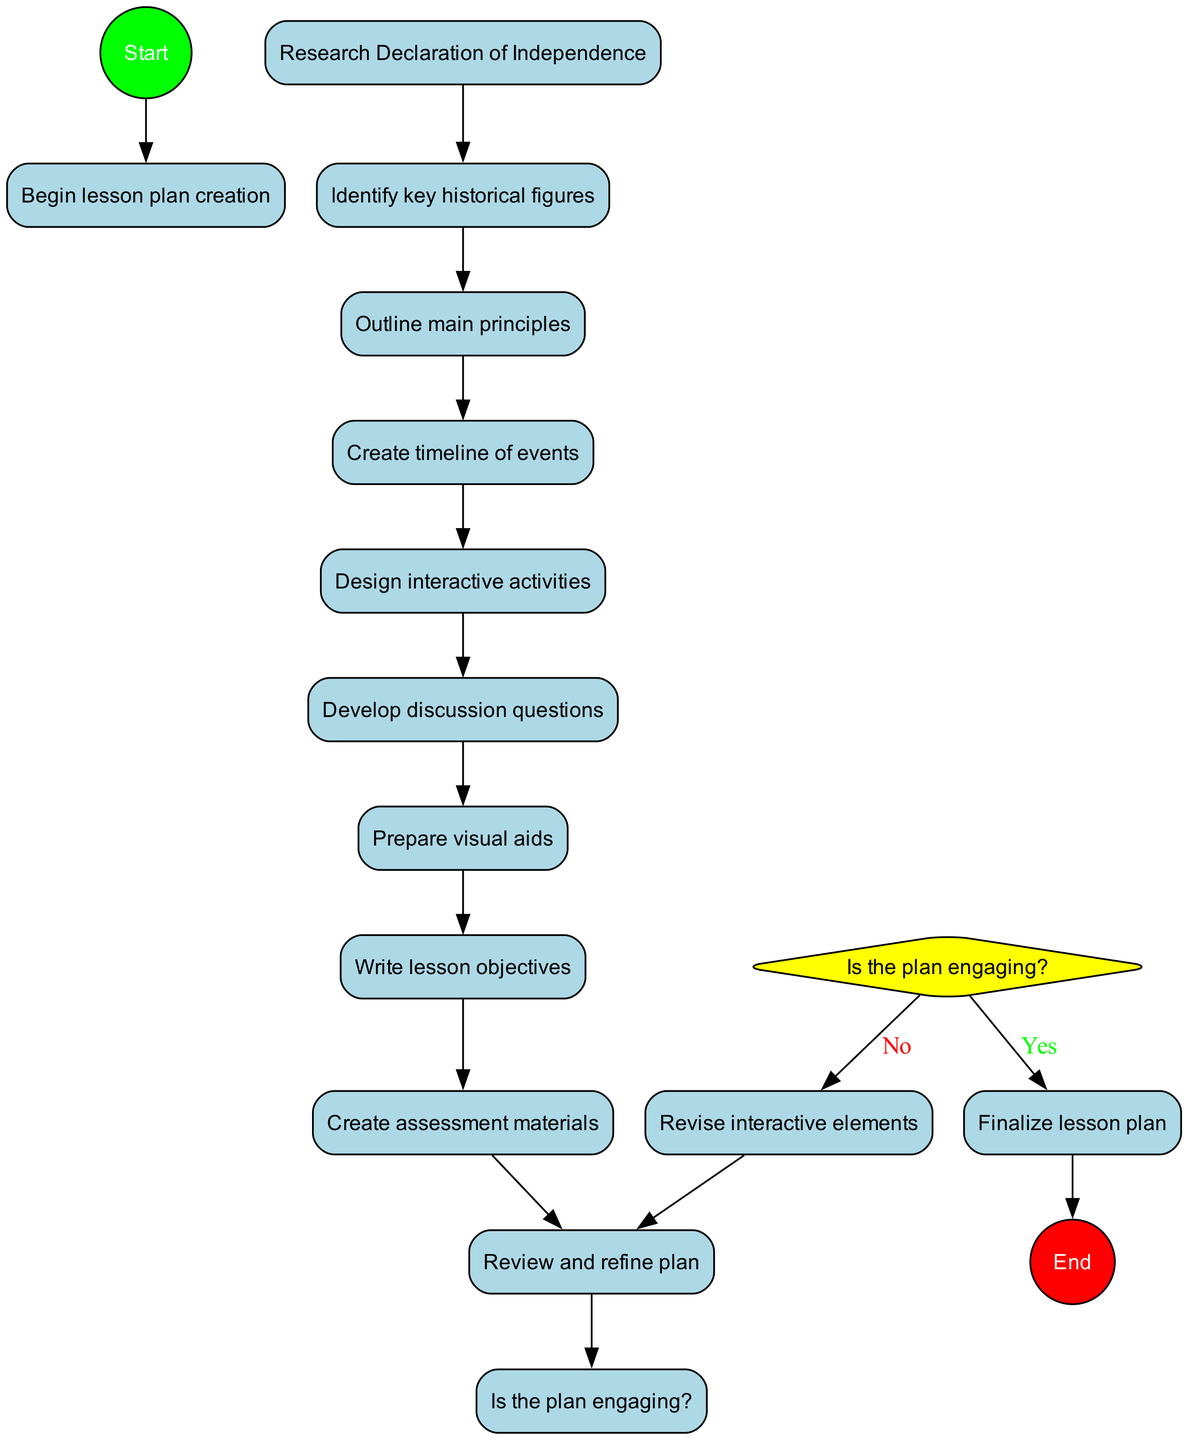What is the first activity in the lesson plan? The first activity listed in the diagram is "Research Declaration of Independence," which starts the process of creating the lesson plan.
Answer: Research Declaration of Independence How many activities are there in the diagram? By counting the listed activities, there are ten activities mentioned, starting from the research phase to the preparation of assessment materials.
Answer: 10 What decision point is included in the diagram? The decision point is whether the plan is engaging, which splits the flow depending on the answer given.
Answer: Is the plan engaging? What happens if the plan is not engaging? If the plan is deemed not engaging, the flow leads to "Revise interactive elements," which suggests a revision process before proceeding.
Answer: Revise interactive elements Which activity comes immediately before preparing visual aids? The activity that comes immediately before "Prepare visual aids" is "Develop discussion questions," indicating the sequential flow of tasks in the lesson plan creation.
Answer: Develop discussion questions What is the last activity before finalizing the lesson plan? The last activity before reaching the decision node is "Review and refine plan," which is crucial for ensuring the plan's quality before it's finalized.
Answer: Review and refine plan If the plan is engaging, what is the next step? If the plan is engaging, it flows directly to finalizing the lesson plan before implementation in the classroom.
Answer: Finalize lesson plan How does one return to reviewing the plan if the interactive elements were revised? After revising the interactive elements, there is a connection that leads back to the "Review and refine plan" node, indicating an iterative process of improvement.
Answer: Review and refine plan How many connections are there in the diagram? Counting all the direct relationships between nodes, there are eleven connections shown in the diagram that link activities and decision points together.
Answer: 11 